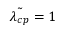<formula> <loc_0><loc_0><loc_500><loc_500>\tilde { \lambda _ { c p } } = 1</formula> 